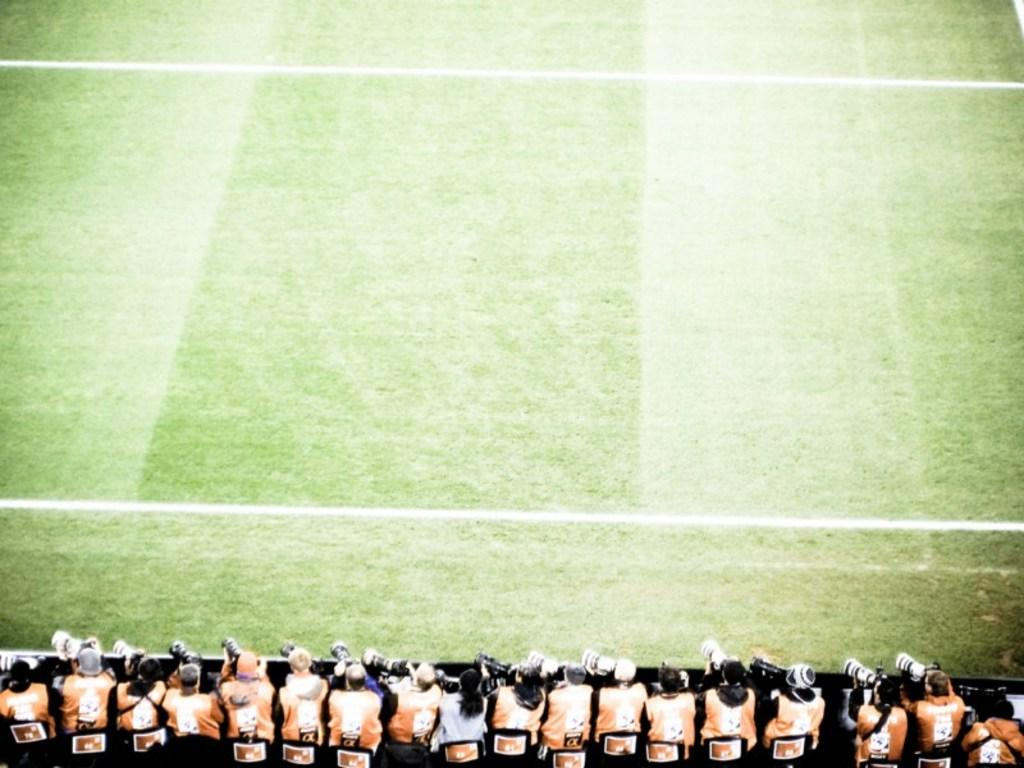What are the people at the bottom of the image doing? The people at the bottom of the image are holding cameras at the fence. What is the surface that the people are standing on? There is ground visible in the background of the image, and it has grass on it. Are there any markings on the ground? Yes, there are two horizontal lines on the ground. What type of wound can be seen on the army soldier in the image? There is no army soldier or wound present in the image. How can one join the people holding cameras in the image? The image does not provide information on how to join the people holding cameras; it only shows them at the fence. 